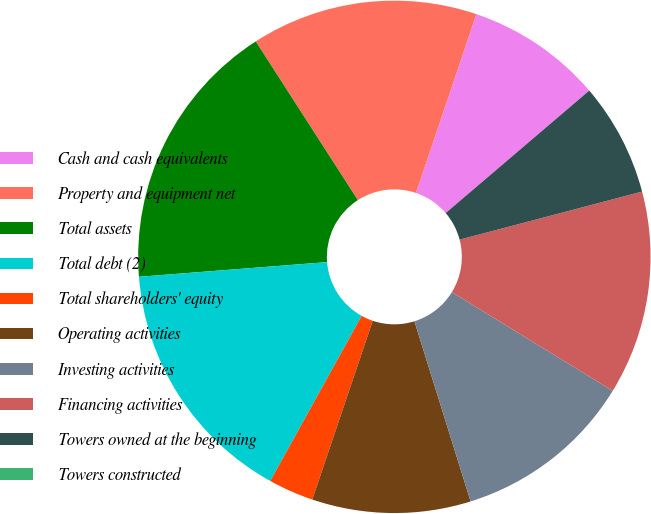Convert chart. <chart><loc_0><loc_0><loc_500><loc_500><pie_chart><fcel>Cash and cash equivalents<fcel>Property and equipment net<fcel>Total assets<fcel>Total debt (2)<fcel>Total shareholders' equity<fcel>Operating activities<fcel>Investing activities<fcel>Financing activities<fcel>Towers owned at the beginning<fcel>Towers constructed<nl><fcel>8.57%<fcel>14.29%<fcel>17.14%<fcel>15.71%<fcel>2.86%<fcel>10.0%<fcel>11.43%<fcel>12.86%<fcel>7.14%<fcel>0.0%<nl></chart> 